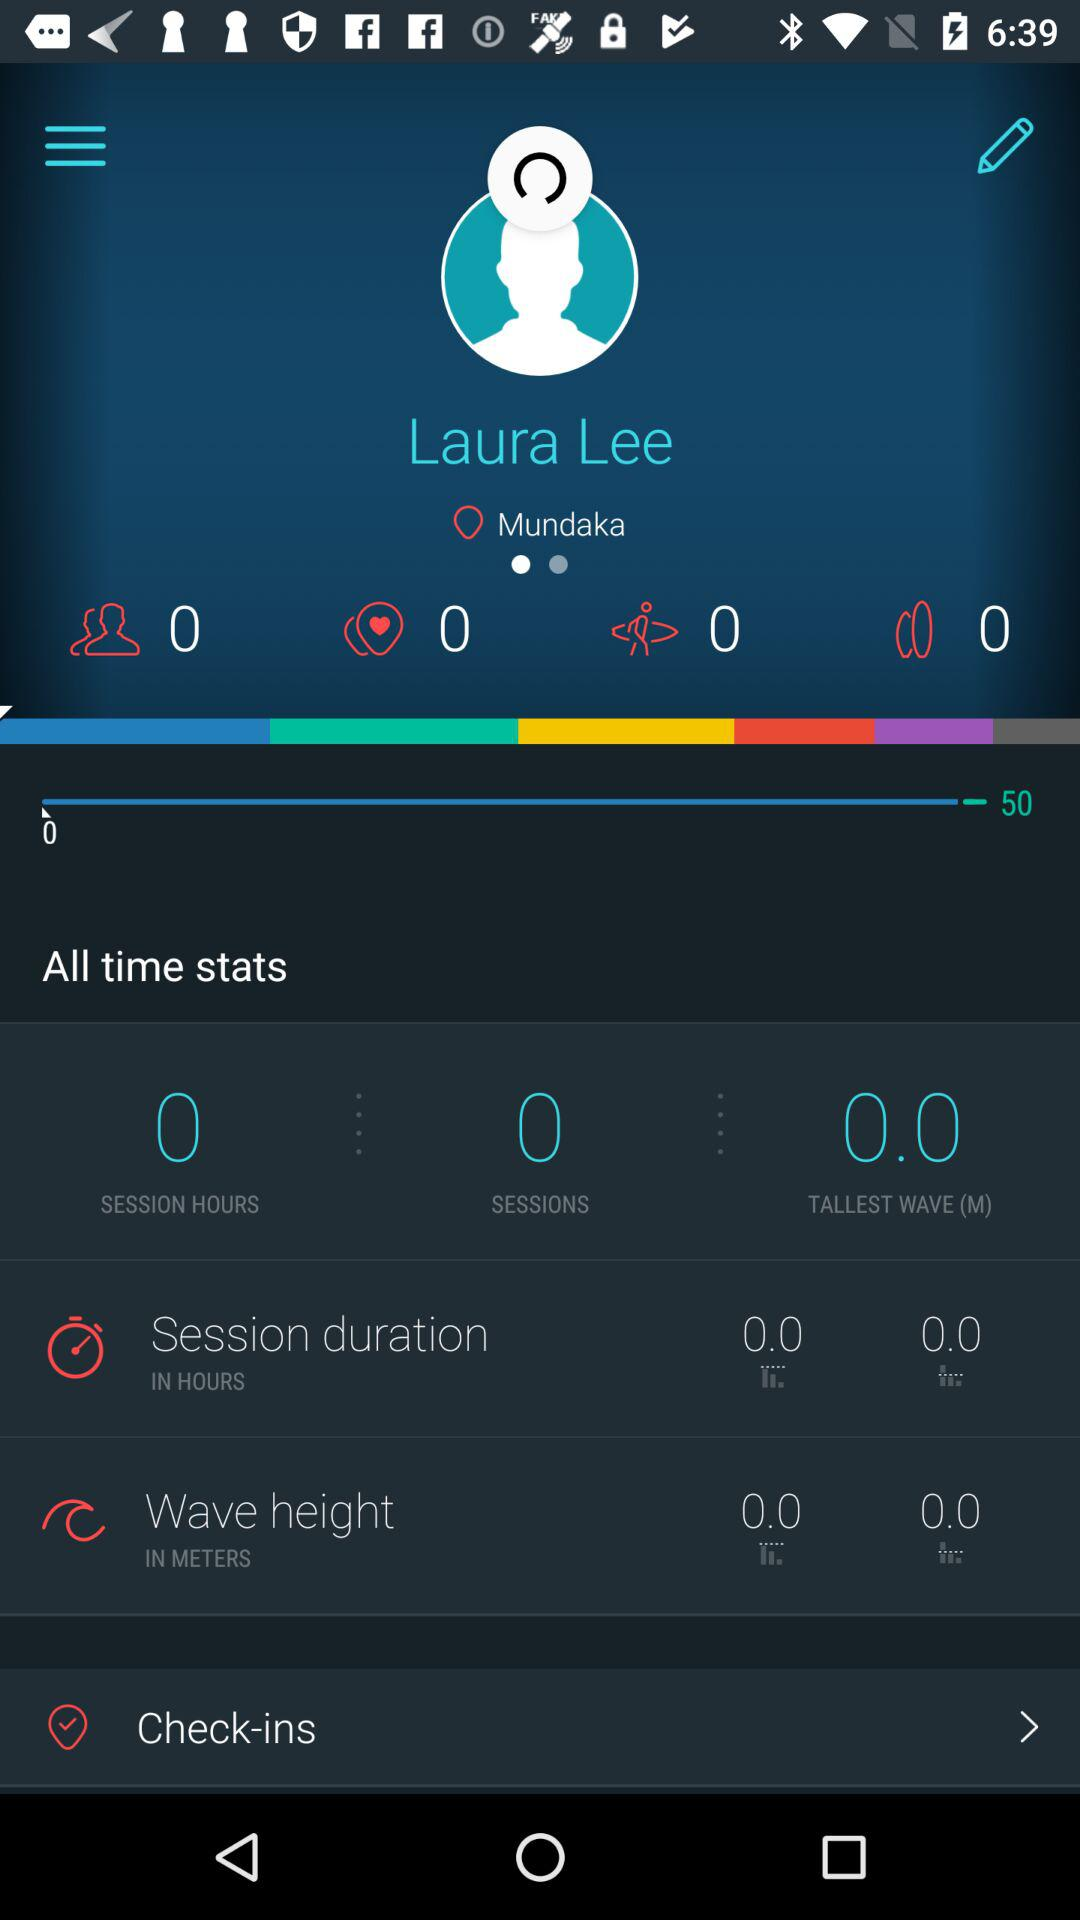What is the user name? The user name is Laura Lee. 